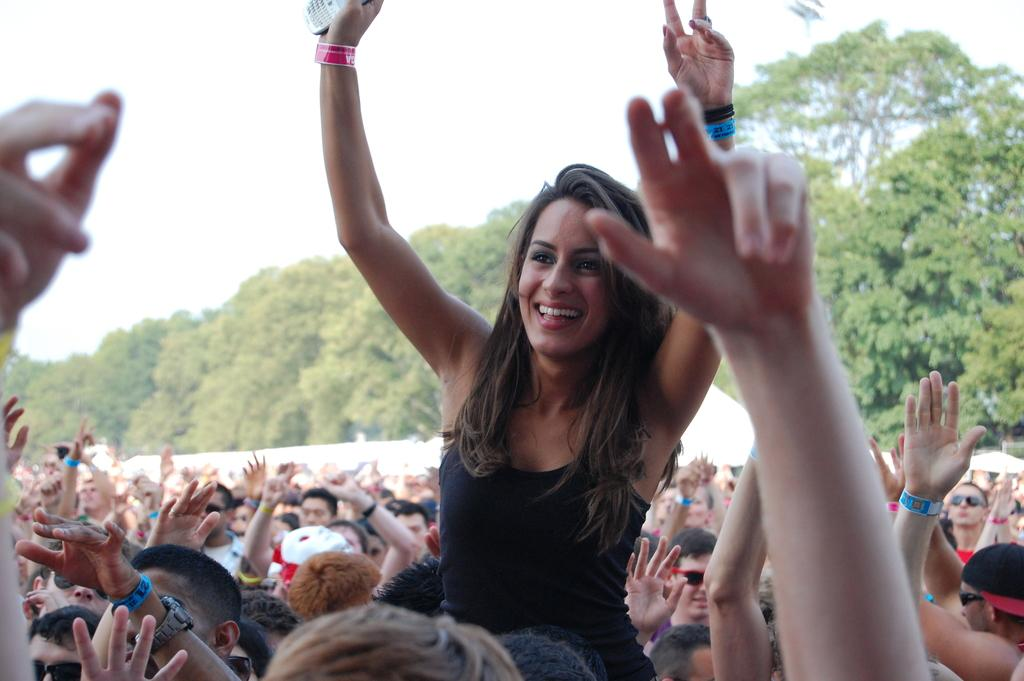What is the main subject in the front of the image? There is a crowd in the front of the image. Can you describe the woman among the crowd? A woman is holding a mobile and smiling among the crowd. What can be seen in the background of the image? There are trees and the sky visible in the background of the image. What type of marble is being used to build the quartz structure in the image? There is no marble or quartz structure present in the image. 